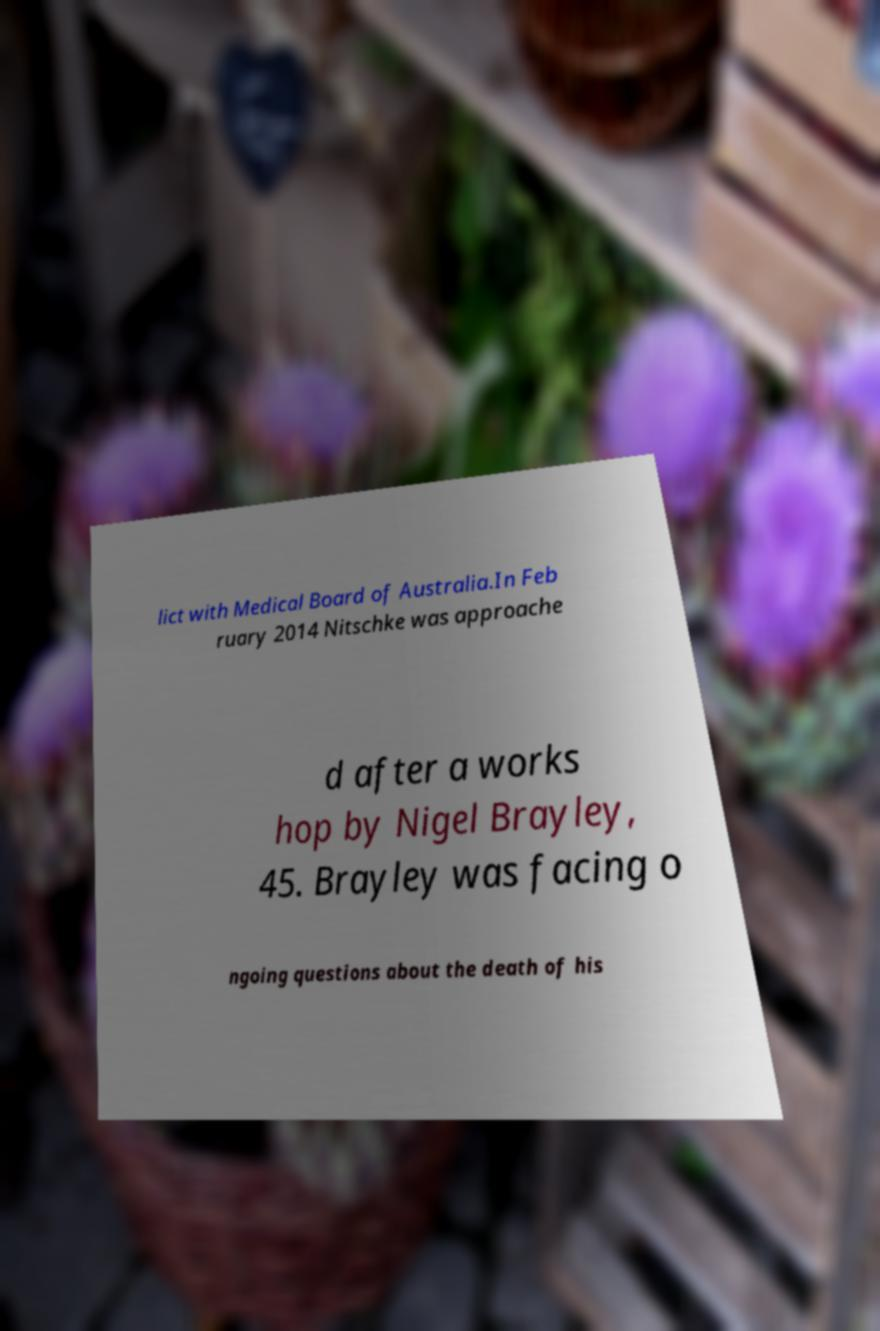Could you extract and type out the text from this image? lict with Medical Board of Australia.In Feb ruary 2014 Nitschke was approache d after a works hop by Nigel Brayley, 45. Brayley was facing o ngoing questions about the death of his 